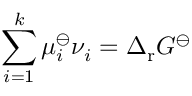Convert formula to latex. <formula><loc_0><loc_0><loc_500><loc_500>\sum _ { i = 1 } ^ { k } \mu _ { i } ^ { \ominus } \nu _ { i } = \Delta _ { r } G ^ { \ominus }</formula> 